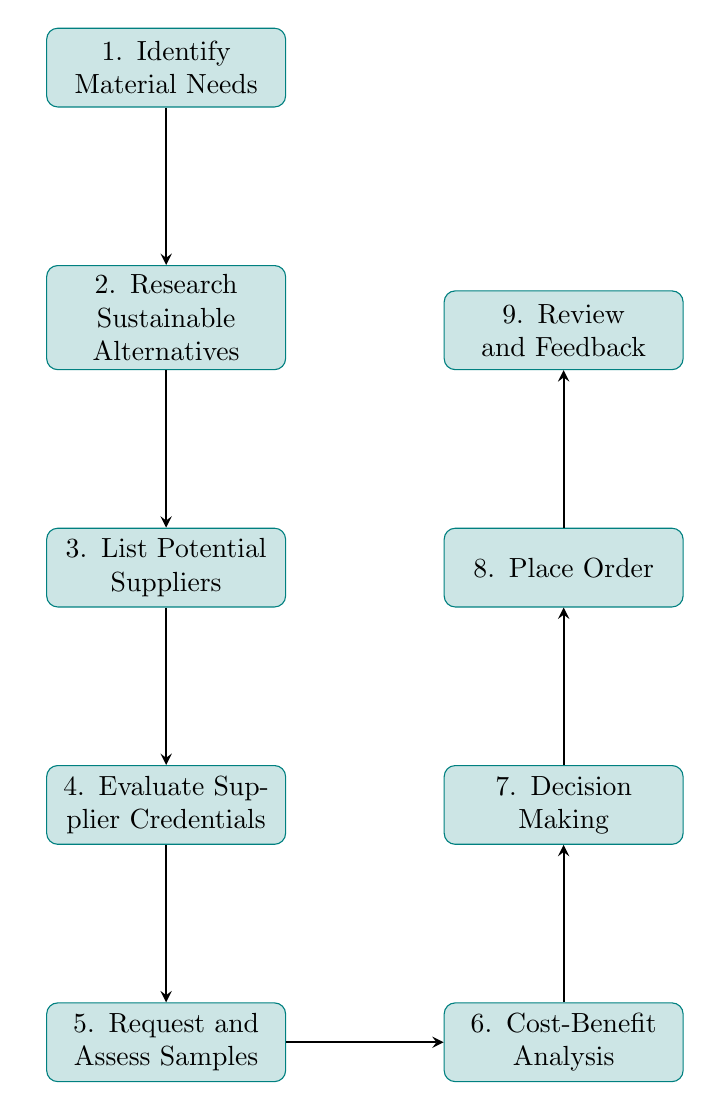What is the first step in the supplier evaluation process? The first step is represented by the top node in the diagram, which is labeled "Identify Material Needs." This sets the foundation for all subsequent steps in the flow.
Answer: Identify Material Needs How many nodes are present in the diagram? By counting each of the distinct steps represented visually in the flow chart, we can verify that there are a total of nine nodes.
Answer: Nine What is the purpose of evaluating supplier credentials? This step involves checking for recognized certifications to ensure that the suppliers meet certain standards for sustainability and quality, reinforcing the importance of using credible sources.
Answer: Check suppliers' certifications Which step follows "Request and Assess Samples"? This question seeks to identify the next action in the flow; after obtaining and evaluating samples, the process moves on to performing a "Cost-Benefit Analysis."
Answer: Cost-Benefit Analysis If a supplier is selected, what is the next action taken? After making a decision on which supplier to choose, the next action is to "Place Order" for the selected sustainable materials, continuing the workflow of the chart.
Answer: Place Order What certification is checked when evaluating supplier credentials for paper products? The certification specifically mentioned for paper products in the flow chart is FSC, which stands for the Forest Stewardship Council. This certification indicates responsible sourcing.
Answer: FSC What does the "Review and Feedback" step entail? This final step involves periodically assessing the performance of the materials provided by the supplier and giving feedback for potential improvements, emphasizing a commitment to quality sustainability.
Answer: Periodic review and feedback How many connections (links) are there in the flow chart? The number of connections in the diagram can be deduced by counting each arrow that indicates a flow or transition between nodes, resulting in a total of eight connections.
Answer: Eight What is the overall direction of the flow chart? The flow of the chart moves from the top to the bottom, indicating a sequential process from identifying needs to providing feedback, demonstrating a structured evaluation process.
Answer: Top to bottom 